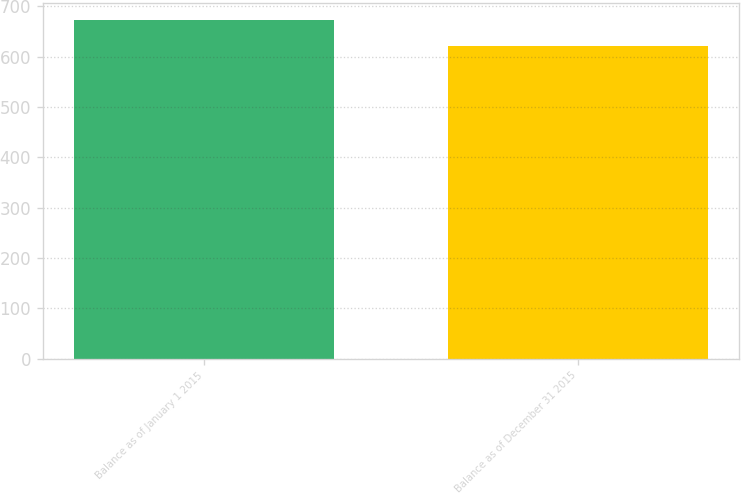Convert chart to OTSL. <chart><loc_0><loc_0><loc_500><loc_500><bar_chart><fcel>Balance as of January 1 2015<fcel>Balance as of December 31 2015<nl><fcel>673<fcel>620<nl></chart> 